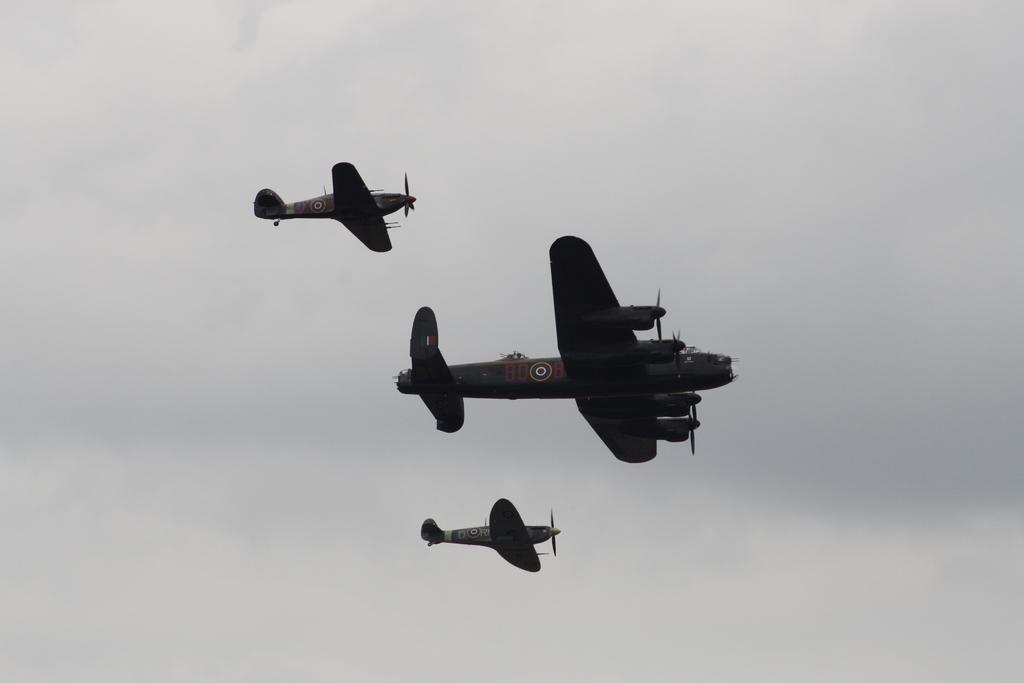What is the main subject of the picture? The main subject of the picture is aircrafts, which are located in the center of the image. How would you describe the sky in the picture? The sky in the picture is cloudy. How many fish can be seen swimming in the sky in the image? There are no fish visible in the image, as it features aircrafts and a cloudy sky. What type of bean is being taught in the picture? There is no bean or teaching activity present in the image. 